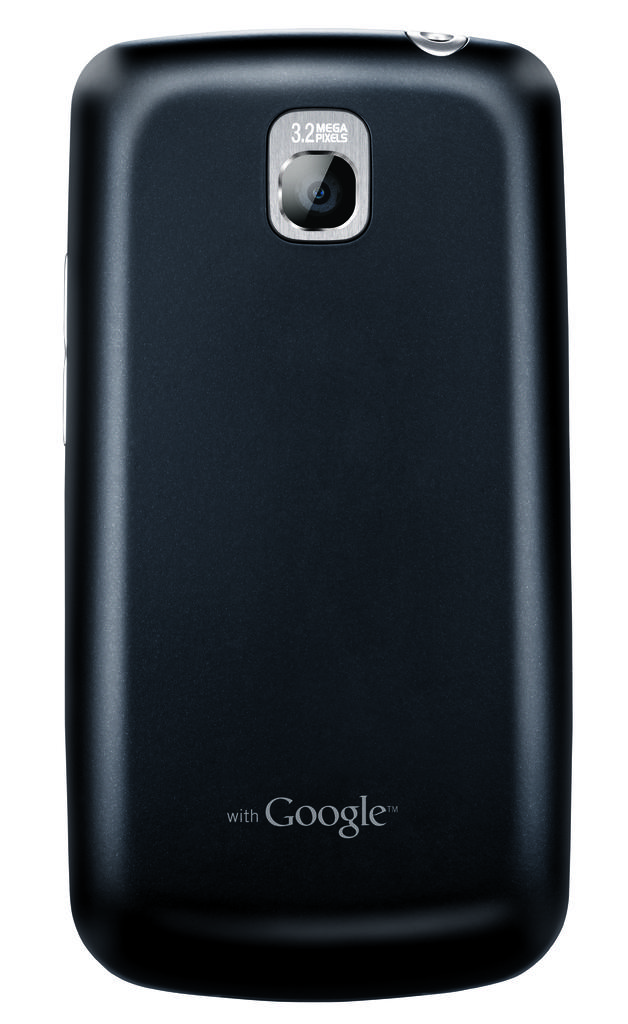What phone type is this?
Offer a very short reply. Google. How many mega pixels camera does this phone have?
Provide a succinct answer. 3.2. 